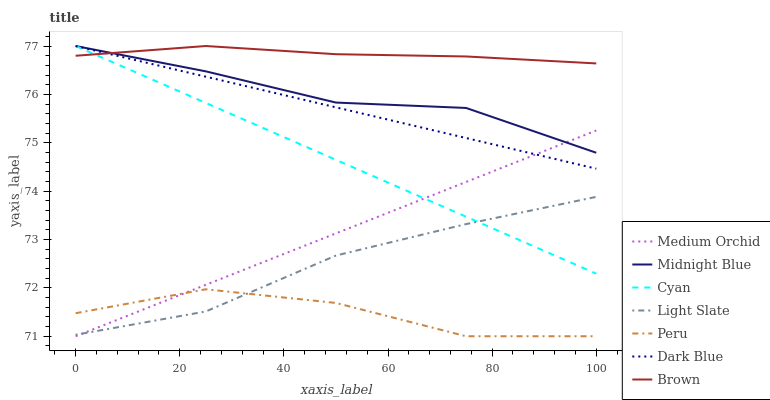Does Midnight Blue have the minimum area under the curve?
Answer yes or no. No. Does Midnight Blue have the maximum area under the curve?
Answer yes or no. No. Is Midnight Blue the smoothest?
Answer yes or no. No. Is Midnight Blue the roughest?
Answer yes or no. No. Does Midnight Blue have the lowest value?
Answer yes or no. No. Does Light Slate have the highest value?
Answer yes or no. No. Is Medium Orchid less than Brown?
Answer yes or no. Yes. Is Dark Blue greater than Peru?
Answer yes or no. Yes. Does Medium Orchid intersect Brown?
Answer yes or no. No. 